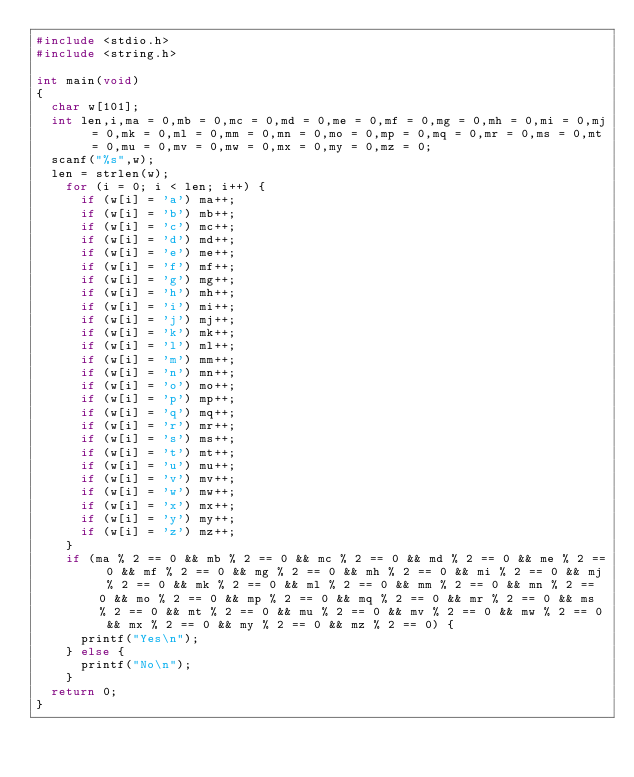<code> <loc_0><loc_0><loc_500><loc_500><_C_>#include <stdio.h>
#include <string.h>
 
int main(void)
{
  char w[101];
  int len,i,ma = 0,mb = 0,mc = 0,md = 0,me = 0,mf = 0,mg = 0,mh = 0,mi = 0,mj = 0,mk = 0,ml = 0,mm = 0,mn = 0,mo = 0,mp = 0,mq = 0,mr = 0,ms = 0,mt = 0,mu = 0,mv = 0,mw = 0,mx = 0,my = 0,mz = 0;
  scanf("%s",w);
  len = strlen(w);
    for (i = 0; i < len; i++) {
      if (w[i] = 'a') ma++;
      if (w[i] = 'b') mb++;
      if (w[i] = 'c') mc++;
      if (w[i] = 'd') md++;
      if (w[i] = 'e') me++;
      if (w[i] = 'f') mf++;
      if (w[i] = 'g') mg++;
      if (w[i] = 'h') mh++;
      if (w[i] = 'i') mi++;
      if (w[i] = 'j') mj++;
      if (w[i] = 'k') mk++;
      if (w[i] = 'l') ml++;
      if (w[i] = 'm') mm++;
      if (w[i] = 'n') mn++;
      if (w[i] = 'o') mo++;
      if (w[i] = 'p') mp++;
      if (w[i] = 'q') mq++;
      if (w[i] = 'r') mr++;
      if (w[i] = 's') ms++;
      if (w[i] = 't') mt++;
      if (w[i] = 'u') mu++;
      if (w[i] = 'v') mv++;
      if (w[i] = 'w') mw++;
      if (w[i] = 'x') mx++;
      if (w[i] = 'y') my++;
      if (w[i] = 'z') mz++;
    }
    if (ma % 2 == 0 && mb % 2 == 0 && mc % 2 == 0 && md % 2 == 0 && me % 2 == 0 && mf % 2 == 0 && mg % 2 == 0 && mh % 2 == 0 && mi % 2 == 0 && mj % 2 == 0 && mk % 2 == 0 && ml % 2 == 0 && mm % 2 == 0 && mn % 2 == 0 && mo % 2 == 0 && mp % 2 == 0 && mq % 2 == 0 && mr % 2 == 0 && ms % 2 == 0 && mt % 2 == 0 && mu % 2 == 0 && mv % 2 == 0 && mw % 2 == 0 && mx % 2 == 0 && my % 2 == 0 && mz % 2 == 0) {
      printf("Yes\n");
    } else {
      printf("No\n");
    }
  return 0;
}</code> 